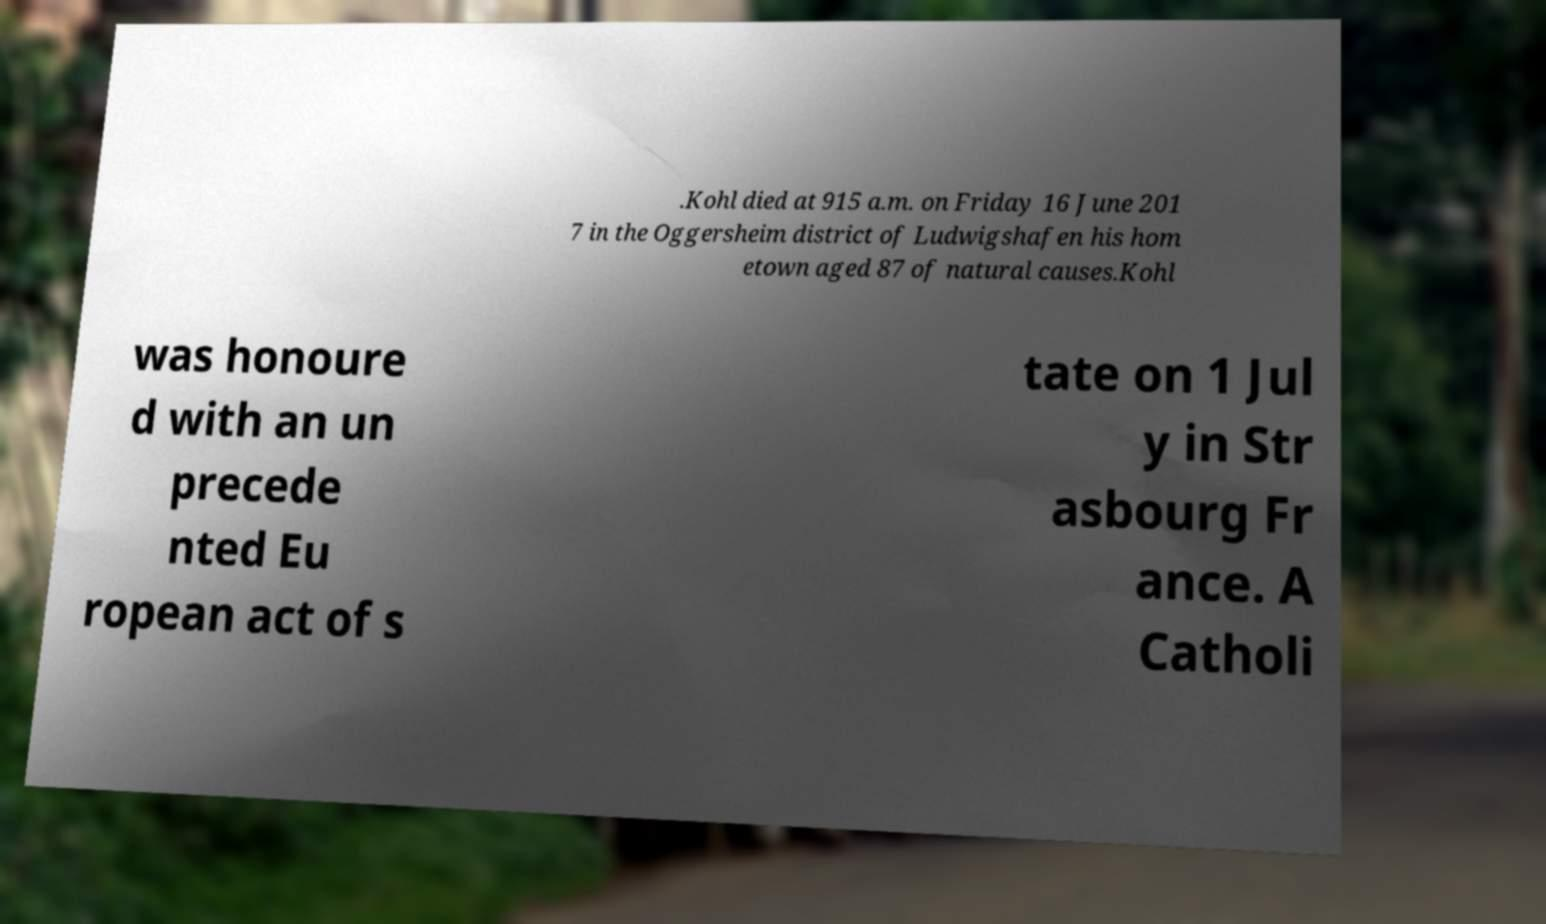I need the written content from this picture converted into text. Can you do that? .Kohl died at 915 a.m. on Friday 16 June 201 7 in the Oggersheim district of Ludwigshafen his hom etown aged 87 of natural causes.Kohl was honoure d with an un precede nted Eu ropean act of s tate on 1 Jul y in Str asbourg Fr ance. A Catholi 